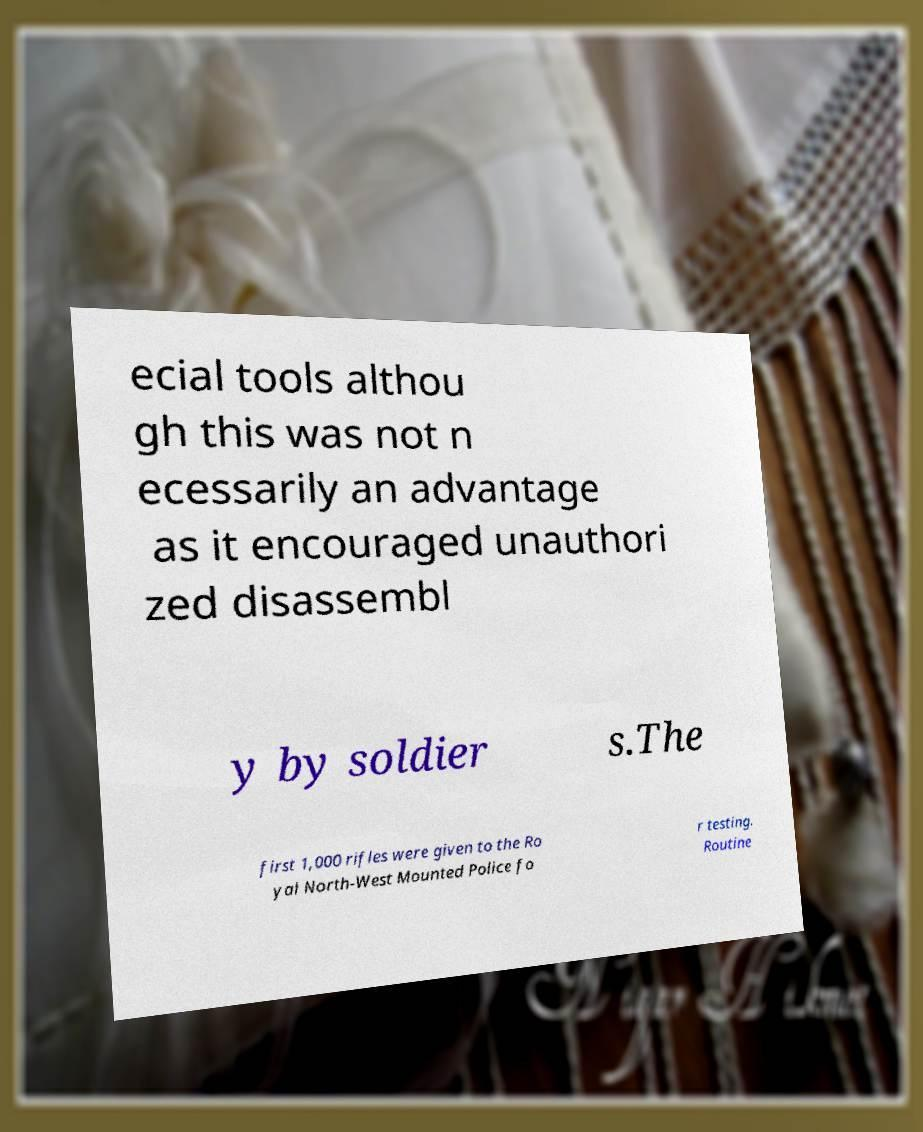Please identify and transcribe the text found in this image. ecial tools althou gh this was not n ecessarily an advantage as it encouraged unauthori zed disassembl y by soldier s.The first 1,000 rifles were given to the Ro yal North-West Mounted Police fo r testing. Routine 